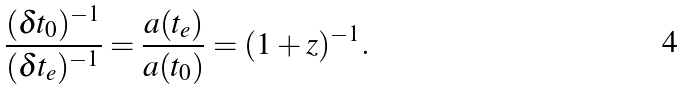<formula> <loc_0><loc_0><loc_500><loc_500>\frac { ( \delta t _ { 0 } ) ^ { - 1 } } { ( \delta t _ { e } ) ^ { - 1 } } = \frac { a ( t _ { e } ) } { a ( t _ { 0 } ) } = ( 1 + z ) ^ { - 1 } .</formula> 